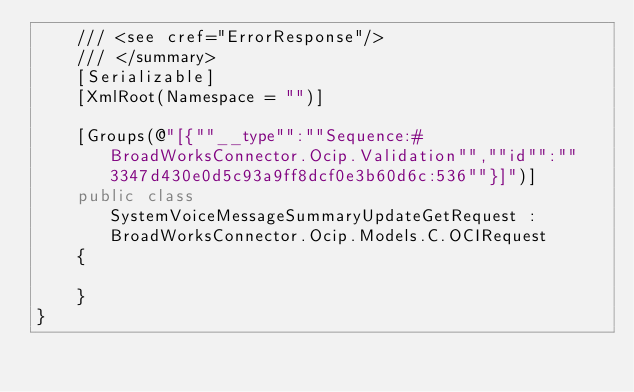Convert code to text. <code><loc_0><loc_0><loc_500><loc_500><_C#_>    /// <see cref="ErrorResponse"/>
    /// </summary>
    [Serializable]
    [XmlRoot(Namespace = "")]

    [Groups(@"[{""__type"":""Sequence:#BroadWorksConnector.Ocip.Validation"",""id"":""3347d430e0d5c93a9ff8dcf0e3b60d6c:536""}]")]
    public class SystemVoiceMessageSummaryUpdateGetRequest : BroadWorksConnector.Ocip.Models.C.OCIRequest
    {

    }
}
</code> 